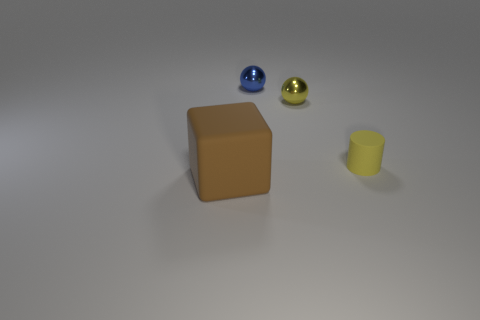Add 1 small blue spheres. How many objects exist? 5 Subtract all cubes. How many objects are left? 3 Add 2 matte cylinders. How many matte cylinders exist? 3 Subtract 0 green blocks. How many objects are left? 4 Subtract all small gray spheres. Subtract all yellow metal objects. How many objects are left? 3 Add 4 blocks. How many blocks are left? 5 